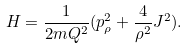<formula> <loc_0><loc_0><loc_500><loc_500>H = \frac { 1 } { 2 m Q ^ { 2 } } ( p _ { \rho } ^ { 2 } + \frac { 4 } { \rho ^ { 2 } } J ^ { 2 } ) .</formula> 